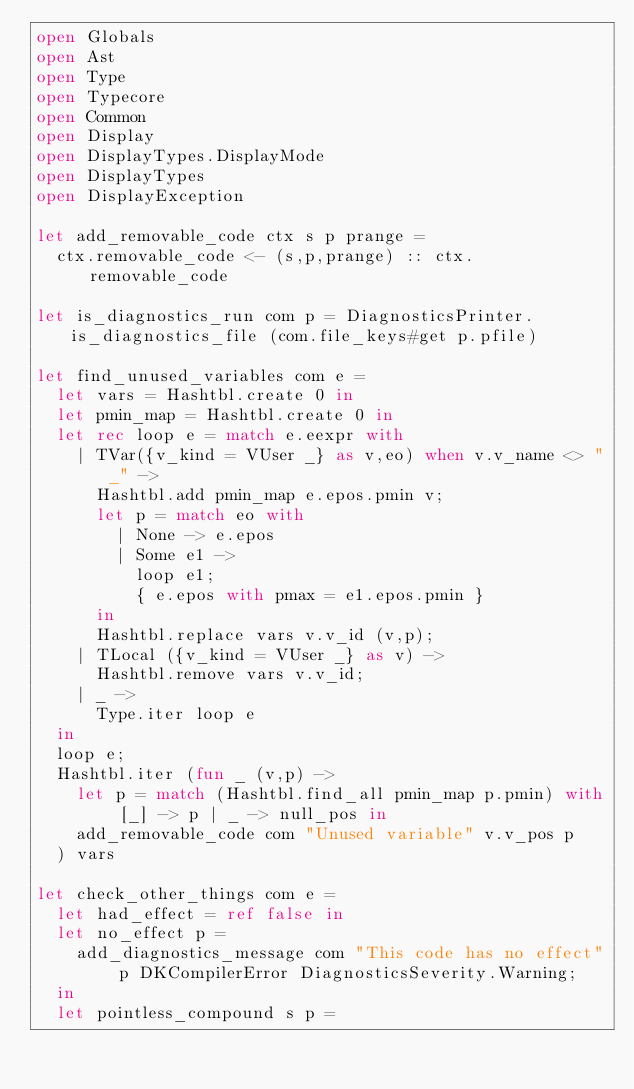Convert code to text. <code><loc_0><loc_0><loc_500><loc_500><_OCaml_>open Globals
open Ast
open Type
open Typecore
open Common
open Display
open DisplayTypes.DisplayMode
open DisplayTypes
open DisplayException

let add_removable_code ctx s p prange =
	ctx.removable_code <- (s,p,prange) :: ctx.removable_code

let is_diagnostics_run com p = DiagnosticsPrinter.is_diagnostics_file (com.file_keys#get p.pfile)

let find_unused_variables com e =
	let vars = Hashtbl.create 0 in
	let pmin_map = Hashtbl.create 0 in
	let rec loop e = match e.eexpr with
		| TVar({v_kind = VUser _} as v,eo) when v.v_name <> "_" ->
			Hashtbl.add pmin_map e.epos.pmin v;
			let p = match eo with
				| None -> e.epos
				| Some e1 ->
					loop e1;
					{ e.epos with pmax = e1.epos.pmin }
			in
			Hashtbl.replace vars v.v_id (v,p);
		| TLocal ({v_kind = VUser _} as v) ->
			Hashtbl.remove vars v.v_id;
		| _ ->
			Type.iter loop e
	in
	loop e;
	Hashtbl.iter (fun _ (v,p) ->
		let p = match (Hashtbl.find_all pmin_map p.pmin) with [_] -> p | _ -> null_pos in
		add_removable_code com "Unused variable" v.v_pos p
	) vars

let check_other_things com e =
	let had_effect = ref false in
	let no_effect p =
		add_diagnostics_message com "This code has no effect" p DKCompilerError DiagnosticsSeverity.Warning;
	in
	let pointless_compound s p =</code> 